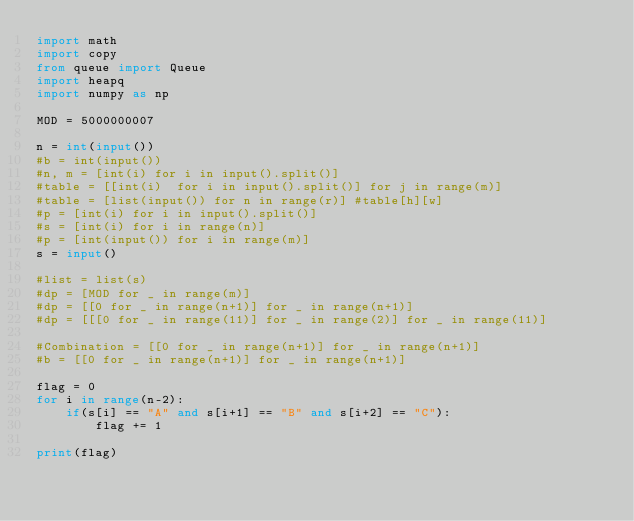Convert code to text. <code><loc_0><loc_0><loc_500><loc_500><_Python_>import math
import copy
from queue import Queue
import heapq
import numpy as np

MOD = 5000000007

n = int(input())
#b = int(input())
#n, m = [int(i) for i in input().split()]
#table = [[int(i)  for i in input().split()] for j in range(m)]
#table = [list(input()) for n in range(r)] #table[h][w]
#p = [int(i) for i in input().split()]
#s = [int(i) for i in range(n)]
#p = [int(input()) for i in range(m)]
s = input()

#list = list(s)
#dp = [MOD for _ in range(m)]
#dp = [[0 for _ in range(n+1)] for _ in range(n+1)]
#dp = [[[0 for _ in range(11)] for _ in range(2)] for _ in range(11)]

#Combination = [[0 for _ in range(n+1)] for _ in range(n+1)]
#b = [[0 for _ in range(n+1)] for _ in range(n+1)]

flag = 0
for i in range(n-2):
    if(s[i] == "A" and s[i+1] == "B" and s[i+2] == "C"):
        flag += 1

print(flag)</code> 